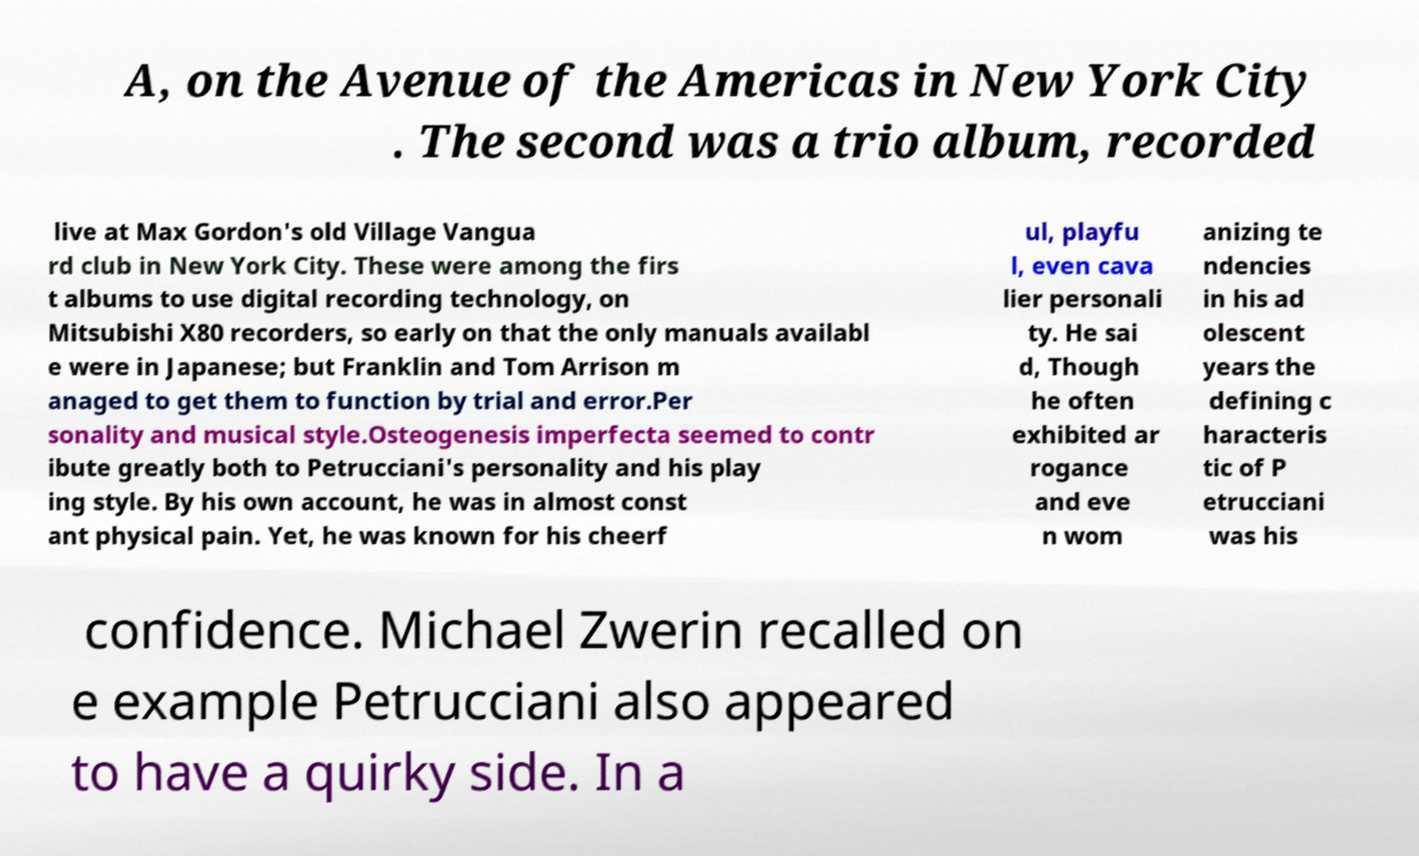There's text embedded in this image that I need extracted. Can you transcribe it verbatim? A, on the Avenue of the Americas in New York City . The second was a trio album, recorded live at Max Gordon's old Village Vangua rd club in New York City. These were among the firs t albums to use digital recording technology, on Mitsubishi X80 recorders, so early on that the only manuals availabl e were in Japanese; but Franklin and Tom Arrison m anaged to get them to function by trial and error.Per sonality and musical style.Osteogenesis imperfecta seemed to contr ibute greatly both to Petrucciani's personality and his play ing style. By his own account, he was in almost const ant physical pain. Yet, he was known for his cheerf ul, playfu l, even cava lier personali ty. He sai d, Though he often exhibited ar rogance and eve n wom anizing te ndencies in his ad olescent years the defining c haracteris tic of P etrucciani was his confidence. Michael Zwerin recalled on e example Petrucciani also appeared to have a quirky side. In a 